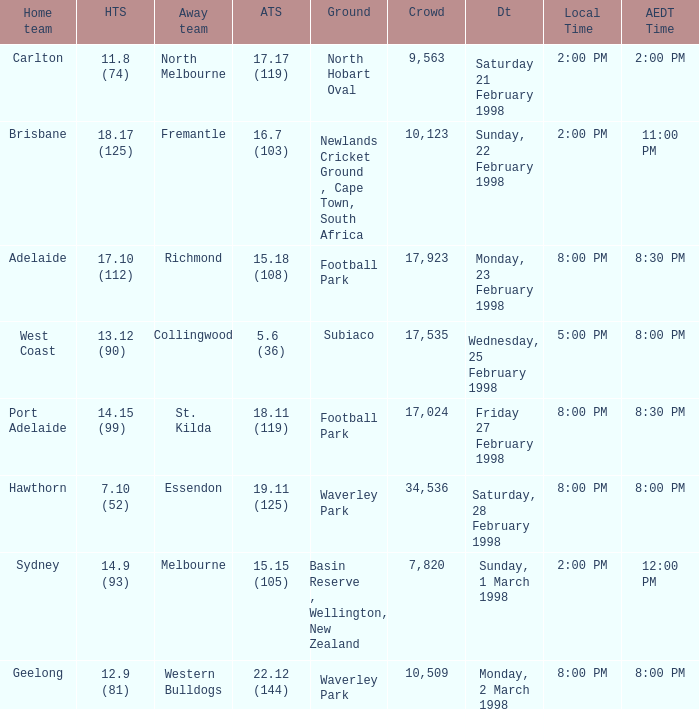Name the Away team which has a Ground of waverley park, and a Home team of hawthorn? Essendon. 